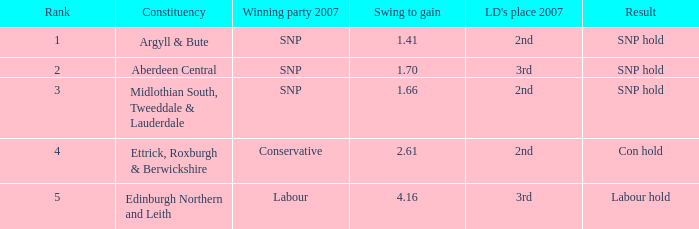What is the lowest standing when the voting district is edinburgh northern and leith, and the swing to acquire is less than None. Could you help me parse every detail presented in this table? {'header': ['Rank', 'Constituency', 'Winning party 2007', 'Swing to gain', "LD's place 2007", 'Result'], 'rows': [['1', 'Argyll & Bute', 'SNP', '1.41', '2nd', 'SNP hold'], ['2', 'Aberdeen Central', 'SNP', '1.70', '3rd', 'SNP hold'], ['3', 'Midlothian South, Tweeddale & Lauderdale', 'SNP', '1.66', '2nd', 'SNP hold'], ['4', 'Ettrick, Roxburgh & Berwickshire', 'Conservative', '2.61', '2nd', 'Con hold'], ['5', 'Edinburgh Northern and Leith', 'Labour', '4.16', '3rd', 'Labour hold']]} 